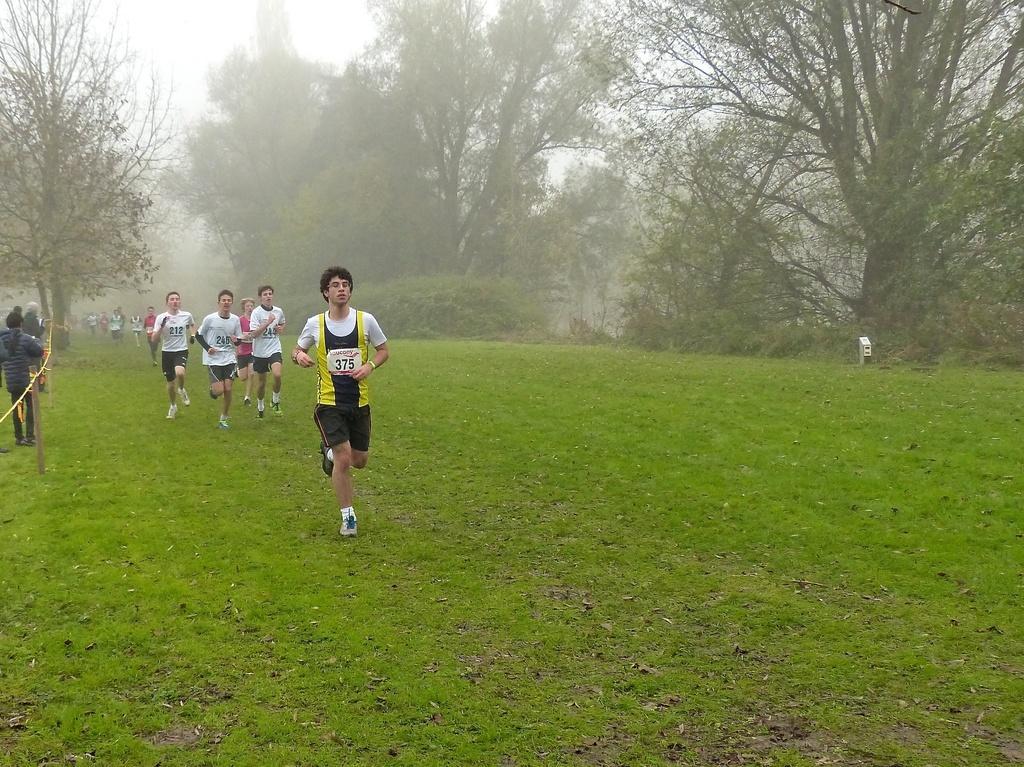Describe this image in one or two sentences. In this image, we can see a few people. Among them, some people are wearing T-shirt and shorts. We can see the ground covered with grass and leaves. There are a few trees and plants. We can see a white colored object on the ground. We can see the sky. We can see some poles with fence. 